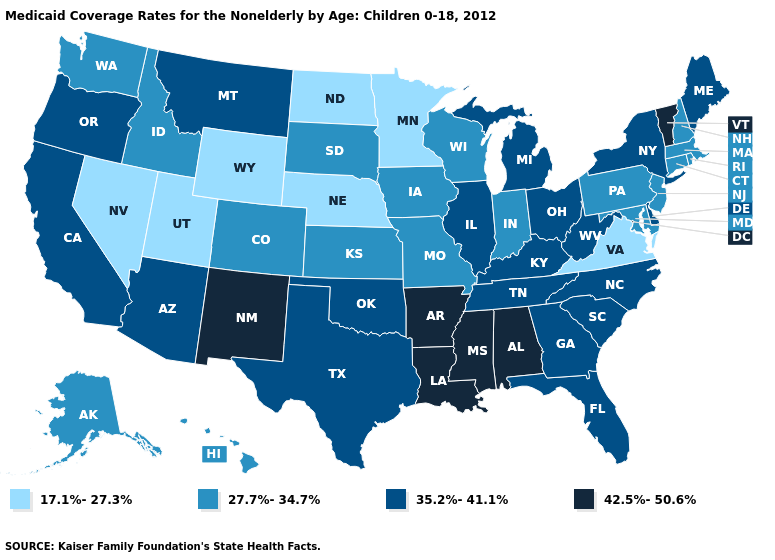Among the states that border Florida , which have the highest value?
Concise answer only. Alabama. Name the states that have a value in the range 35.2%-41.1%?
Concise answer only. Arizona, California, Delaware, Florida, Georgia, Illinois, Kentucky, Maine, Michigan, Montana, New York, North Carolina, Ohio, Oklahoma, Oregon, South Carolina, Tennessee, Texas, West Virginia. What is the lowest value in the West?
Keep it brief. 17.1%-27.3%. What is the value of Idaho?
Quick response, please. 27.7%-34.7%. Name the states that have a value in the range 27.7%-34.7%?
Write a very short answer. Alaska, Colorado, Connecticut, Hawaii, Idaho, Indiana, Iowa, Kansas, Maryland, Massachusetts, Missouri, New Hampshire, New Jersey, Pennsylvania, Rhode Island, South Dakota, Washington, Wisconsin. Among the states that border Michigan , does Wisconsin have the highest value?
Be succinct. No. What is the value of Alabama?
Concise answer only. 42.5%-50.6%. Which states have the lowest value in the USA?
Give a very brief answer. Minnesota, Nebraska, Nevada, North Dakota, Utah, Virginia, Wyoming. Does Vermont have the highest value in the Northeast?
Quick response, please. Yes. What is the value of Illinois?
Give a very brief answer. 35.2%-41.1%. Name the states that have a value in the range 35.2%-41.1%?
Be succinct. Arizona, California, Delaware, Florida, Georgia, Illinois, Kentucky, Maine, Michigan, Montana, New York, North Carolina, Ohio, Oklahoma, Oregon, South Carolina, Tennessee, Texas, West Virginia. What is the lowest value in the USA?
Give a very brief answer. 17.1%-27.3%. Does Kentucky have a lower value than Nevada?
Give a very brief answer. No. What is the highest value in the South ?
Concise answer only. 42.5%-50.6%. Name the states that have a value in the range 27.7%-34.7%?
Quick response, please. Alaska, Colorado, Connecticut, Hawaii, Idaho, Indiana, Iowa, Kansas, Maryland, Massachusetts, Missouri, New Hampshire, New Jersey, Pennsylvania, Rhode Island, South Dakota, Washington, Wisconsin. 